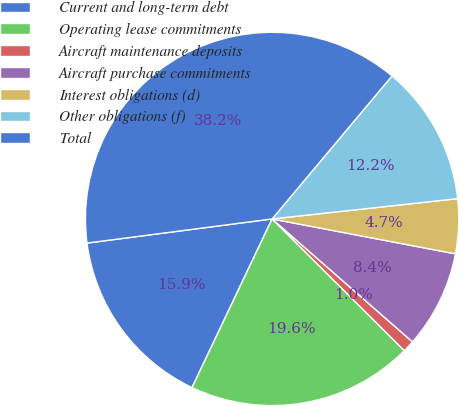Convert chart. <chart><loc_0><loc_0><loc_500><loc_500><pie_chart><fcel>Current and long-term debt<fcel>Operating lease commitments<fcel>Aircraft maintenance deposits<fcel>Aircraft purchase commitments<fcel>Interest obligations (d)<fcel>Other obligations (f)<fcel>Total<nl><fcel>15.88%<fcel>19.59%<fcel>1.02%<fcel>8.45%<fcel>4.73%<fcel>12.16%<fcel>38.17%<nl></chart> 